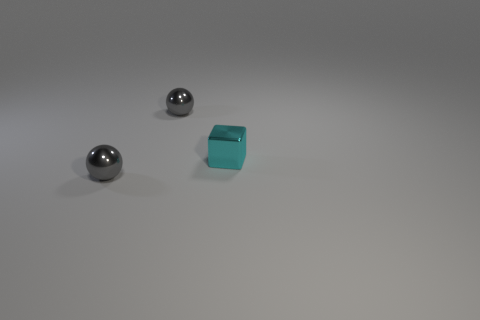Add 2 small red cubes. How many objects exist? 5 Subtract all cubes. How many objects are left? 2 Add 1 small rubber things. How many small rubber things exist? 1 Subtract 0 yellow cylinders. How many objects are left? 3 Subtract all cyan things. Subtract all cyan metal blocks. How many objects are left? 1 Add 3 cyan metal things. How many cyan metal things are left? 4 